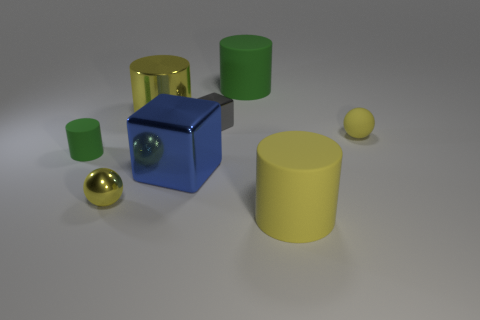Add 1 big yellow matte cylinders. How many objects exist? 9 Subtract all balls. How many objects are left? 6 Add 5 tiny brown spheres. How many tiny brown spheres exist? 5 Subtract 1 yellow spheres. How many objects are left? 7 Subtract all blue shiny cubes. Subtract all yellow metal things. How many objects are left? 5 Add 3 yellow shiny balls. How many yellow shiny balls are left? 4 